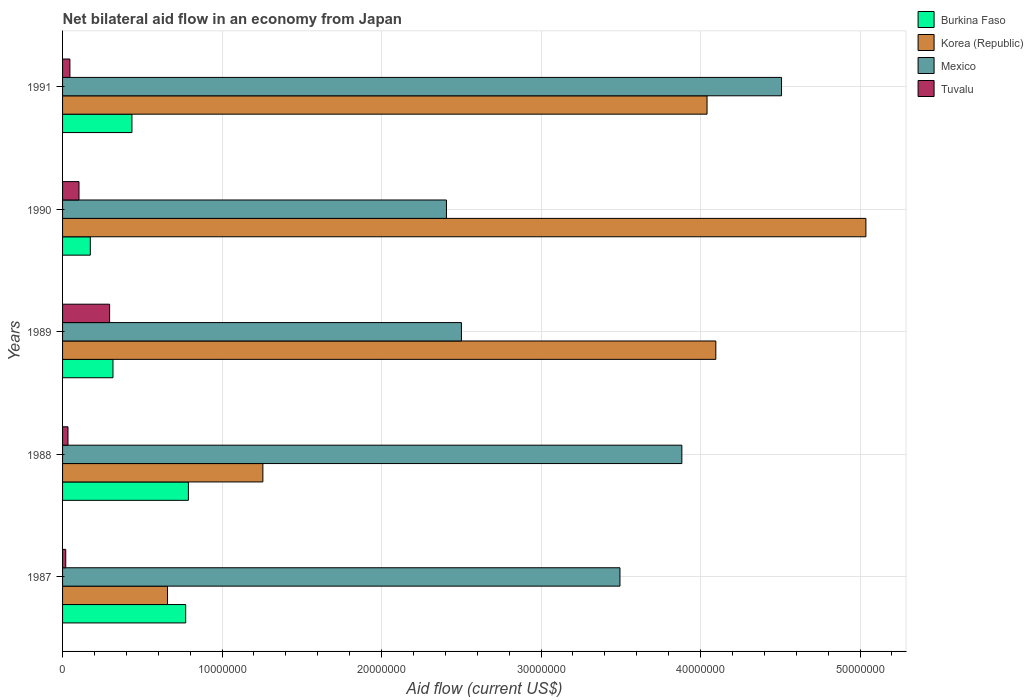How many different coloured bars are there?
Your answer should be compact. 4. How many groups of bars are there?
Keep it short and to the point. 5. Are the number of bars on each tick of the Y-axis equal?
Give a very brief answer. Yes. How many bars are there on the 1st tick from the bottom?
Your response must be concise. 4. What is the label of the 4th group of bars from the top?
Your answer should be compact. 1988. In how many cases, is the number of bars for a given year not equal to the number of legend labels?
Give a very brief answer. 0. What is the net bilateral aid flow in Mexico in 1988?
Make the answer very short. 3.88e+07. Across all years, what is the maximum net bilateral aid flow in Korea (Republic)?
Offer a terse response. 5.04e+07. Across all years, what is the minimum net bilateral aid flow in Mexico?
Provide a succinct answer. 2.41e+07. In which year was the net bilateral aid flow in Tuvalu minimum?
Keep it short and to the point. 1987. What is the total net bilateral aid flow in Tuvalu in the graph?
Your answer should be compact. 4.98e+06. What is the difference between the net bilateral aid flow in Mexico in 1987 and that in 1990?
Provide a succinct answer. 1.09e+07. What is the difference between the net bilateral aid flow in Burkina Faso in 1990 and the net bilateral aid flow in Korea (Republic) in 1989?
Keep it short and to the point. -3.92e+07. What is the average net bilateral aid flow in Mexico per year?
Ensure brevity in your answer.  3.36e+07. In the year 1989, what is the difference between the net bilateral aid flow in Mexico and net bilateral aid flow in Tuvalu?
Ensure brevity in your answer.  2.21e+07. In how many years, is the net bilateral aid flow in Burkina Faso greater than 20000000 US$?
Keep it short and to the point. 0. What is the ratio of the net bilateral aid flow in Tuvalu in 1987 to that in 1990?
Your answer should be very brief. 0.19. Is the net bilateral aid flow in Mexico in 1988 less than that in 1991?
Offer a terse response. Yes. Is the difference between the net bilateral aid flow in Mexico in 1987 and 1990 greater than the difference between the net bilateral aid flow in Tuvalu in 1987 and 1990?
Give a very brief answer. Yes. What is the difference between the highest and the second highest net bilateral aid flow in Mexico?
Keep it short and to the point. 6.25e+06. What is the difference between the highest and the lowest net bilateral aid flow in Burkina Faso?
Your answer should be compact. 6.15e+06. Is the sum of the net bilateral aid flow in Tuvalu in 1987 and 1988 greater than the maximum net bilateral aid flow in Korea (Republic) across all years?
Your answer should be very brief. No. Is it the case that in every year, the sum of the net bilateral aid flow in Burkina Faso and net bilateral aid flow in Tuvalu is greater than the sum of net bilateral aid flow in Mexico and net bilateral aid flow in Korea (Republic)?
Offer a terse response. Yes. What does the 4th bar from the top in 1990 represents?
Provide a succinct answer. Burkina Faso. What does the 1st bar from the bottom in 1989 represents?
Offer a very short reply. Burkina Faso. How many bars are there?
Ensure brevity in your answer.  20. Are the values on the major ticks of X-axis written in scientific E-notation?
Give a very brief answer. No. Does the graph contain any zero values?
Your response must be concise. No. How many legend labels are there?
Your response must be concise. 4. What is the title of the graph?
Provide a succinct answer. Net bilateral aid flow in an economy from Japan. What is the label or title of the X-axis?
Your answer should be compact. Aid flow (current US$). What is the label or title of the Y-axis?
Provide a short and direct response. Years. What is the Aid flow (current US$) in Burkina Faso in 1987?
Offer a very short reply. 7.72e+06. What is the Aid flow (current US$) in Korea (Republic) in 1987?
Give a very brief answer. 6.58e+06. What is the Aid flow (current US$) of Mexico in 1987?
Give a very brief answer. 3.50e+07. What is the Aid flow (current US$) in Tuvalu in 1987?
Make the answer very short. 2.00e+05. What is the Aid flow (current US$) in Burkina Faso in 1988?
Provide a succinct answer. 7.89e+06. What is the Aid flow (current US$) in Korea (Republic) in 1988?
Offer a very short reply. 1.26e+07. What is the Aid flow (current US$) in Mexico in 1988?
Make the answer very short. 3.88e+07. What is the Aid flow (current US$) in Tuvalu in 1988?
Provide a short and direct response. 3.40e+05. What is the Aid flow (current US$) in Burkina Faso in 1989?
Provide a succinct answer. 3.16e+06. What is the Aid flow (current US$) in Korea (Republic) in 1989?
Your answer should be very brief. 4.10e+07. What is the Aid flow (current US$) of Mexico in 1989?
Your answer should be very brief. 2.50e+07. What is the Aid flow (current US$) of Tuvalu in 1989?
Keep it short and to the point. 2.95e+06. What is the Aid flow (current US$) in Burkina Faso in 1990?
Offer a very short reply. 1.74e+06. What is the Aid flow (current US$) of Korea (Republic) in 1990?
Offer a very short reply. 5.04e+07. What is the Aid flow (current US$) in Mexico in 1990?
Ensure brevity in your answer.  2.41e+07. What is the Aid flow (current US$) in Tuvalu in 1990?
Provide a succinct answer. 1.03e+06. What is the Aid flow (current US$) in Burkina Faso in 1991?
Your response must be concise. 4.35e+06. What is the Aid flow (current US$) of Korea (Republic) in 1991?
Provide a succinct answer. 4.04e+07. What is the Aid flow (current US$) of Mexico in 1991?
Offer a terse response. 4.51e+07. Across all years, what is the maximum Aid flow (current US$) in Burkina Faso?
Offer a terse response. 7.89e+06. Across all years, what is the maximum Aid flow (current US$) in Korea (Republic)?
Make the answer very short. 5.04e+07. Across all years, what is the maximum Aid flow (current US$) of Mexico?
Provide a succinct answer. 4.51e+07. Across all years, what is the maximum Aid flow (current US$) in Tuvalu?
Ensure brevity in your answer.  2.95e+06. Across all years, what is the minimum Aid flow (current US$) in Burkina Faso?
Give a very brief answer. 1.74e+06. Across all years, what is the minimum Aid flow (current US$) in Korea (Republic)?
Your answer should be very brief. 6.58e+06. Across all years, what is the minimum Aid flow (current US$) of Mexico?
Ensure brevity in your answer.  2.41e+07. What is the total Aid flow (current US$) of Burkina Faso in the graph?
Give a very brief answer. 2.49e+07. What is the total Aid flow (current US$) of Korea (Republic) in the graph?
Give a very brief answer. 1.51e+08. What is the total Aid flow (current US$) of Mexico in the graph?
Provide a succinct answer. 1.68e+08. What is the total Aid flow (current US$) of Tuvalu in the graph?
Provide a succinct answer. 4.98e+06. What is the difference between the Aid flow (current US$) in Korea (Republic) in 1987 and that in 1988?
Give a very brief answer. -5.98e+06. What is the difference between the Aid flow (current US$) of Mexico in 1987 and that in 1988?
Offer a very short reply. -3.88e+06. What is the difference between the Aid flow (current US$) in Tuvalu in 1987 and that in 1988?
Provide a short and direct response. -1.40e+05. What is the difference between the Aid flow (current US$) of Burkina Faso in 1987 and that in 1989?
Ensure brevity in your answer.  4.56e+06. What is the difference between the Aid flow (current US$) of Korea (Republic) in 1987 and that in 1989?
Provide a succinct answer. -3.44e+07. What is the difference between the Aid flow (current US$) in Mexico in 1987 and that in 1989?
Your response must be concise. 9.94e+06. What is the difference between the Aid flow (current US$) of Tuvalu in 1987 and that in 1989?
Make the answer very short. -2.75e+06. What is the difference between the Aid flow (current US$) in Burkina Faso in 1987 and that in 1990?
Your answer should be very brief. 5.98e+06. What is the difference between the Aid flow (current US$) of Korea (Republic) in 1987 and that in 1990?
Offer a very short reply. -4.38e+07. What is the difference between the Aid flow (current US$) in Mexico in 1987 and that in 1990?
Your answer should be very brief. 1.09e+07. What is the difference between the Aid flow (current US$) of Tuvalu in 1987 and that in 1990?
Offer a terse response. -8.30e+05. What is the difference between the Aid flow (current US$) of Burkina Faso in 1987 and that in 1991?
Ensure brevity in your answer.  3.37e+06. What is the difference between the Aid flow (current US$) in Korea (Republic) in 1987 and that in 1991?
Your response must be concise. -3.38e+07. What is the difference between the Aid flow (current US$) of Mexico in 1987 and that in 1991?
Your response must be concise. -1.01e+07. What is the difference between the Aid flow (current US$) in Burkina Faso in 1988 and that in 1989?
Offer a very short reply. 4.73e+06. What is the difference between the Aid flow (current US$) in Korea (Republic) in 1988 and that in 1989?
Your response must be concise. -2.84e+07. What is the difference between the Aid flow (current US$) of Mexico in 1988 and that in 1989?
Make the answer very short. 1.38e+07. What is the difference between the Aid flow (current US$) in Tuvalu in 1988 and that in 1989?
Offer a very short reply. -2.61e+06. What is the difference between the Aid flow (current US$) of Burkina Faso in 1988 and that in 1990?
Ensure brevity in your answer.  6.15e+06. What is the difference between the Aid flow (current US$) in Korea (Republic) in 1988 and that in 1990?
Provide a short and direct response. -3.78e+07. What is the difference between the Aid flow (current US$) in Mexico in 1988 and that in 1990?
Make the answer very short. 1.48e+07. What is the difference between the Aid flow (current US$) of Tuvalu in 1988 and that in 1990?
Offer a very short reply. -6.90e+05. What is the difference between the Aid flow (current US$) in Burkina Faso in 1988 and that in 1991?
Give a very brief answer. 3.54e+06. What is the difference between the Aid flow (current US$) of Korea (Republic) in 1988 and that in 1991?
Your response must be concise. -2.78e+07. What is the difference between the Aid flow (current US$) in Mexico in 1988 and that in 1991?
Keep it short and to the point. -6.25e+06. What is the difference between the Aid flow (current US$) of Burkina Faso in 1989 and that in 1990?
Keep it short and to the point. 1.42e+06. What is the difference between the Aid flow (current US$) of Korea (Republic) in 1989 and that in 1990?
Provide a short and direct response. -9.41e+06. What is the difference between the Aid flow (current US$) of Mexico in 1989 and that in 1990?
Ensure brevity in your answer.  9.40e+05. What is the difference between the Aid flow (current US$) of Tuvalu in 1989 and that in 1990?
Provide a short and direct response. 1.92e+06. What is the difference between the Aid flow (current US$) in Burkina Faso in 1989 and that in 1991?
Offer a very short reply. -1.19e+06. What is the difference between the Aid flow (current US$) in Korea (Republic) in 1989 and that in 1991?
Ensure brevity in your answer.  5.50e+05. What is the difference between the Aid flow (current US$) in Mexico in 1989 and that in 1991?
Provide a short and direct response. -2.01e+07. What is the difference between the Aid flow (current US$) of Tuvalu in 1989 and that in 1991?
Offer a very short reply. 2.49e+06. What is the difference between the Aid flow (current US$) of Burkina Faso in 1990 and that in 1991?
Ensure brevity in your answer.  -2.61e+06. What is the difference between the Aid flow (current US$) in Korea (Republic) in 1990 and that in 1991?
Make the answer very short. 9.96e+06. What is the difference between the Aid flow (current US$) of Mexico in 1990 and that in 1991?
Your answer should be very brief. -2.10e+07. What is the difference between the Aid flow (current US$) of Tuvalu in 1990 and that in 1991?
Provide a succinct answer. 5.70e+05. What is the difference between the Aid flow (current US$) in Burkina Faso in 1987 and the Aid flow (current US$) in Korea (Republic) in 1988?
Your answer should be compact. -4.84e+06. What is the difference between the Aid flow (current US$) in Burkina Faso in 1987 and the Aid flow (current US$) in Mexico in 1988?
Offer a very short reply. -3.11e+07. What is the difference between the Aid flow (current US$) of Burkina Faso in 1987 and the Aid flow (current US$) of Tuvalu in 1988?
Your response must be concise. 7.38e+06. What is the difference between the Aid flow (current US$) of Korea (Republic) in 1987 and the Aid flow (current US$) of Mexico in 1988?
Your answer should be compact. -3.22e+07. What is the difference between the Aid flow (current US$) of Korea (Republic) in 1987 and the Aid flow (current US$) of Tuvalu in 1988?
Your answer should be compact. 6.24e+06. What is the difference between the Aid flow (current US$) of Mexico in 1987 and the Aid flow (current US$) of Tuvalu in 1988?
Your answer should be very brief. 3.46e+07. What is the difference between the Aid flow (current US$) of Burkina Faso in 1987 and the Aid flow (current US$) of Korea (Republic) in 1989?
Provide a succinct answer. -3.32e+07. What is the difference between the Aid flow (current US$) in Burkina Faso in 1987 and the Aid flow (current US$) in Mexico in 1989?
Keep it short and to the point. -1.73e+07. What is the difference between the Aid flow (current US$) in Burkina Faso in 1987 and the Aid flow (current US$) in Tuvalu in 1989?
Your answer should be very brief. 4.77e+06. What is the difference between the Aid flow (current US$) in Korea (Republic) in 1987 and the Aid flow (current US$) in Mexico in 1989?
Your answer should be very brief. -1.84e+07. What is the difference between the Aid flow (current US$) in Korea (Republic) in 1987 and the Aid flow (current US$) in Tuvalu in 1989?
Give a very brief answer. 3.63e+06. What is the difference between the Aid flow (current US$) of Mexico in 1987 and the Aid flow (current US$) of Tuvalu in 1989?
Offer a terse response. 3.20e+07. What is the difference between the Aid flow (current US$) in Burkina Faso in 1987 and the Aid flow (current US$) in Korea (Republic) in 1990?
Provide a short and direct response. -4.26e+07. What is the difference between the Aid flow (current US$) in Burkina Faso in 1987 and the Aid flow (current US$) in Mexico in 1990?
Your response must be concise. -1.64e+07. What is the difference between the Aid flow (current US$) in Burkina Faso in 1987 and the Aid flow (current US$) in Tuvalu in 1990?
Give a very brief answer. 6.69e+06. What is the difference between the Aid flow (current US$) in Korea (Republic) in 1987 and the Aid flow (current US$) in Mexico in 1990?
Provide a succinct answer. -1.75e+07. What is the difference between the Aid flow (current US$) in Korea (Republic) in 1987 and the Aid flow (current US$) in Tuvalu in 1990?
Your answer should be compact. 5.55e+06. What is the difference between the Aid flow (current US$) of Mexico in 1987 and the Aid flow (current US$) of Tuvalu in 1990?
Make the answer very short. 3.39e+07. What is the difference between the Aid flow (current US$) in Burkina Faso in 1987 and the Aid flow (current US$) in Korea (Republic) in 1991?
Give a very brief answer. -3.27e+07. What is the difference between the Aid flow (current US$) in Burkina Faso in 1987 and the Aid flow (current US$) in Mexico in 1991?
Give a very brief answer. -3.74e+07. What is the difference between the Aid flow (current US$) of Burkina Faso in 1987 and the Aid flow (current US$) of Tuvalu in 1991?
Your response must be concise. 7.26e+06. What is the difference between the Aid flow (current US$) in Korea (Republic) in 1987 and the Aid flow (current US$) in Mexico in 1991?
Your answer should be very brief. -3.85e+07. What is the difference between the Aid flow (current US$) in Korea (Republic) in 1987 and the Aid flow (current US$) in Tuvalu in 1991?
Make the answer very short. 6.12e+06. What is the difference between the Aid flow (current US$) of Mexico in 1987 and the Aid flow (current US$) of Tuvalu in 1991?
Give a very brief answer. 3.45e+07. What is the difference between the Aid flow (current US$) of Burkina Faso in 1988 and the Aid flow (current US$) of Korea (Republic) in 1989?
Offer a very short reply. -3.31e+07. What is the difference between the Aid flow (current US$) in Burkina Faso in 1988 and the Aid flow (current US$) in Mexico in 1989?
Ensure brevity in your answer.  -1.71e+07. What is the difference between the Aid flow (current US$) in Burkina Faso in 1988 and the Aid flow (current US$) in Tuvalu in 1989?
Your response must be concise. 4.94e+06. What is the difference between the Aid flow (current US$) in Korea (Republic) in 1988 and the Aid flow (current US$) in Mexico in 1989?
Offer a terse response. -1.24e+07. What is the difference between the Aid flow (current US$) in Korea (Republic) in 1988 and the Aid flow (current US$) in Tuvalu in 1989?
Keep it short and to the point. 9.61e+06. What is the difference between the Aid flow (current US$) of Mexico in 1988 and the Aid flow (current US$) of Tuvalu in 1989?
Give a very brief answer. 3.59e+07. What is the difference between the Aid flow (current US$) in Burkina Faso in 1988 and the Aid flow (current US$) in Korea (Republic) in 1990?
Your answer should be very brief. -4.25e+07. What is the difference between the Aid flow (current US$) of Burkina Faso in 1988 and the Aid flow (current US$) of Mexico in 1990?
Offer a terse response. -1.62e+07. What is the difference between the Aid flow (current US$) in Burkina Faso in 1988 and the Aid flow (current US$) in Tuvalu in 1990?
Offer a very short reply. 6.86e+06. What is the difference between the Aid flow (current US$) in Korea (Republic) in 1988 and the Aid flow (current US$) in Mexico in 1990?
Your answer should be compact. -1.15e+07. What is the difference between the Aid flow (current US$) of Korea (Republic) in 1988 and the Aid flow (current US$) of Tuvalu in 1990?
Give a very brief answer. 1.15e+07. What is the difference between the Aid flow (current US$) of Mexico in 1988 and the Aid flow (current US$) of Tuvalu in 1990?
Make the answer very short. 3.78e+07. What is the difference between the Aid flow (current US$) in Burkina Faso in 1988 and the Aid flow (current US$) in Korea (Republic) in 1991?
Provide a succinct answer. -3.25e+07. What is the difference between the Aid flow (current US$) in Burkina Faso in 1988 and the Aid flow (current US$) in Mexico in 1991?
Your answer should be very brief. -3.72e+07. What is the difference between the Aid flow (current US$) of Burkina Faso in 1988 and the Aid flow (current US$) of Tuvalu in 1991?
Your answer should be compact. 7.43e+06. What is the difference between the Aid flow (current US$) in Korea (Republic) in 1988 and the Aid flow (current US$) in Mexico in 1991?
Offer a very short reply. -3.25e+07. What is the difference between the Aid flow (current US$) of Korea (Republic) in 1988 and the Aid flow (current US$) of Tuvalu in 1991?
Ensure brevity in your answer.  1.21e+07. What is the difference between the Aid flow (current US$) of Mexico in 1988 and the Aid flow (current US$) of Tuvalu in 1991?
Offer a terse response. 3.84e+07. What is the difference between the Aid flow (current US$) of Burkina Faso in 1989 and the Aid flow (current US$) of Korea (Republic) in 1990?
Offer a very short reply. -4.72e+07. What is the difference between the Aid flow (current US$) of Burkina Faso in 1989 and the Aid flow (current US$) of Mexico in 1990?
Give a very brief answer. -2.09e+07. What is the difference between the Aid flow (current US$) in Burkina Faso in 1989 and the Aid flow (current US$) in Tuvalu in 1990?
Give a very brief answer. 2.13e+06. What is the difference between the Aid flow (current US$) in Korea (Republic) in 1989 and the Aid flow (current US$) in Mexico in 1990?
Provide a short and direct response. 1.69e+07. What is the difference between the Aid flow (current US$) of Korea (Republic) in 1989 and the Aid flow (current US$) of Tuvalu in 1990?
Your response must be concise. 3.99e+07. What is the difference between the Aid flow (current US$) in Mexico in 1989 and the Aid flow (current US$) in Tuvalu in 1990?
Keep it short and to the point. 2.40e+07. What is the difference between the Aid flow (current US$) in Burkina Faso in 1989 and the Aid flow (current US$) in Korea (Republic) in 1991?
Ensure brevity in your answer.  -3.72e+07. What is the difference between the Aid flow (current US$) in Burkina Faso in 1989 and the Aid flow (current US$) in Mexico in 1991?
Make the answer very short. -4.19e+07. What is the difference between the Aid flow (current US$) in Burkina Faso in 1989 and the Aid flow (current US$) in Tuvalu in 1991?
Your response must be concise. 2.70e+06. What is the difference between the Aid flow (current US$) in Korea (Republic) in 1989 and the Aid flow (current US$) in Mexico in 1991?
Your response must be concise. -4.12e+06. What is the difference between the Aid flow (current US$) of Korea (Republic) in 1989 and the Aid flow (current US$) of Tuvalu in 1991?
Keep it short and to the point. 4.05e+07. What is the difference between the Aid flow (current US$) in Mexico in 1989 and the Aid flow (current US$) in Tuvalu in 1991?
Offer a terse response. 2.46e+07. What is the difference between the Aid flow (current US$) in Burkina Faso in 1990 and the Aid flow (current US$) in Korea (Republic) in 1991?
Offer a terse response. -3.87e+07. What is the difference between the Aid flow (current US$) in Burkina Faso in 1990 and the Aid flow (current US$) in Mexico in 1991?
Your response must be concise. -4.33e+07. What is the difference between the Aid flow (current US$) in Burkina Faso in 1990 and the Aid flow (current US$) in Tuvalu in 1991?
Offer a terse response. 1.28e+06. What is the difference between the Aid flow (current US$) in Korea (Republic) in 1990 and the Aid flow (current US$) in Mexico in 1991?
Provide a short and direct response. 5.29e+06. What is the difference between the Aid flow (current US$) of Korea (Republic) in 1990 and the Aid flow (current US$) of Tuvalu in 1991?
Make the answer very short. 4.99e+07. What is the difference between the Aid flow (current US$) of Mexico in 1990 and the Aid flow (current US$) of Tuvalu in 1991?
Offer a terse response. 2.36e+07. What is the average Aid flow (current US$) of Burkina Faso per year?
Offer a very short reply. 4.97e+06. What is the average Aid flow (current US$) in Korea (Republic) per year?
Offer a terse response. 3.02e+07. What is the average Aid flow (current US$) of Mexico per year?
Ensure brevity in your answer.  3.36e+07. What is the average Aid flow (current US$) in Tuvalu per year?
Offer a very short reply. 9.96e+05. In the year 1987, what is the difference between the Aid flow (current US$) of Burkina Faso and Aid flow (current US$) of Korea (Republic)?
Your answer should be compact. 1.14e+06. In the year 1987, what is the difference between the Aid flow (current US$) in Burkina Faso and Aid flow (current US$) in Mexico?
Offer a terse response. -2.72e+07. In the year 1987, what is the difference between the Aid flow (current US$) in Burkina Faso and Aid flow (current US$) in Tuvalu?
Keep it short and to the point. 7.52e+06. In the year 1987, what is the difference between the Aid flow (current US$) in Korea (Republic) and Aid flow (current US$) in Mexico?
Provide a succinct answer. -2.84e+07. In the year 1987, what is the difference between the Aid flow (current US$) of Korea (Republic) and Aid flow (current US$) of Tuvalu?
Provide a succinct answer. 6.38e+06. In the year 1987, what is the difference between the Aid flow (current US$) of Mexico and Aid flow (current US$) of Tuvalu?
Offer a very short reply. 3.48e+07. In the year 1988, what is the difference between the Aid flow (current US$) of Burkina Faso and Aid flow (current US$) of Korea (Republic)?
Give a very brief answer. -4.67e+06. In the year 1988, what is the difference between the Aid flow (current US$) in Burkina Faso and Aid flow (current US$) in Mexico?
Ensure brevity in your answer.  -3.09e+07. In the year 1988, what is the difference between the Aid flow (current US$) of Burkina Faso and Aid flow (current US$) of Tuvalu?
Keep it short and to the point. 7.55e+06. In the year 1988, what is the difference between the Aid flow (current US$) of Korea (Republic) and Aid flow (current US$) of Mexico?
Your answer should be compact. -2.63e+07. In the year 1988, what is the difference between the Aid flow (current US$) in Korea (Republic) and Aid flow (current US$) in Tuvalu?
Ensure brevity in your answer.  1.22e+07. In the year 1988, what is the difference between the Aid flow (current US$) of Mexico and Aid flow (current US$) of Tuvalu?
Your response must be concise. 3.85e+07. In the year 1989, what is the difference between the Aid flow (current US$) in Burkina Faso and Aid flow (current US$) in Korea (Republic)?
Your answer should be compact. -3.78e+07. In the year 1989, what is the difference between the Aid flow (current US$) of Burkina Faso and Aid flow (current US$) of Mexico?
Your answer should be compact. -2.18e+07. In the year 1989, what is the difference between the Aid flow (current US$) in Korea (Republic) and Aid flow (current US$) in Mexico?
Ensure brevity in your answer.  1.60e+07. In the year 1989, what is the difference between the Aid flow (current US$) in Korea (Republic) and Aid flow (current US$) in Tuvalu?
Make the answer very short. 3.80e+07. In the year 1989, what is the difference between the Aid flow (current US$) of Mexico and Aid flow (current US$) of Tuvalu?
Your answer should be very brief. 2.21e+07. In the year 1990, what is the difference between the Aid flow (current US$) of Burkina Faso and Aid flow (current US$) of Korea (Republic)?
Give a very brief answer. -4.86e+07. In the year 1990, what is the difference between the Aid flow (current US$) of Burkina Faso and Aid flow (current US$) of Mexico?
Keep it short and to the point. -2.23e+07. In the year 1990, what is the difference between the Aid flow (current US$) of Burkina Faso and Aid flow (current US$) of Tuvalu?
Offer a terse response. 7.10e+05. In the year 1990, what is the difference between the Aid flow (current US$) in Korea (Republic) and Aid flow (current US$) in Mexico?
Keep it short and to the point. 2.63e+07. In the year 1990, what is the difference between the Aid flow (current US$) of Korea (Republic) and Aid flow (current US$) of Tuvalu?
Keep it short and to the point. 4.93e+07. In the year 1990, what is the difference between the Aid flow (current US$) in Mexico and Aid flow (current US$) in Tuvalu?
Your response must be concise. 2.30e+07. In the year 1991, what is the difference between the Aid flow (current US$) in Burkina Faso and Aid flow (current US$) in Korea (Republic)?
Provide a succinct answer. -3.61e+07. In the year 1991, what is the difference between the Aid flow (current US$) of Burkina Faso and Aid flow (current US$) of Mexico?
Provide a succinct answer. -4.07e+07. In the year 1991, what is the difference between the Aid flow (current US$) of Burkina Faso and Aid flow (current US$) of Tuvalu?
Give a very brief answer. 3.89e+06. In the year 1991, what is the difference between the Aid flow (current US$) in Korea (Republic) and Aid flow (current US$) in Mexico?
Ensure brevity in your answer.  -4.67e+06. In the year 1991, what is the difference between the Aid flow (current US$) of Korea (Republic) and Aid flow (current US$) of Tuvalu?
Offer a very short reply. 4.00e+07. In the year 1991, what is the difference between the Aid flow (current US$) in Mexico and Aid flow (current US$) in Tuvalu?
Ensure brevity in your answer.  4.46e+07. What is the ratio of the Aid flow (current US$) in Burkina Faso in 1987 to that in 1988?
Make the answer very short. 0.98. What is the ratio of the Aid flow (current US$) in Korea (Republic) in 1987 to that in 1988?
Your answer should be very brief. 0.52. What is the ratio of the Aid flow (current US$) of Mexico in 1987 to that in 1988?
Your answer should be compact. 0.9. What is the ratio of the Aid flow (current US$) of Tuvalu in 1987 to that in 1988?
Your answer should be very brief. 0.59. What is the ratio of the Aid flow (current US$) of Burkina Faso in 1987 to that in 1989?
Provide a succinct answer. 2.44. What is the ratio of the Aid flow (current US$) of Korea (Republic) in 1987 to that in 1989?
Your answer should be very brief. 0.16. What is the ratio of the Aid flow (current US$) of Mexico in 1987 to that in 1989?
Provide a succinct answer. 1.4. What is the ratio of the Aid flow (current US$) in Tuvalu in 1987 to that in 1989?
Give a very brief answer. 0.07. What is the ratio of the Aid flow (current US$) in Burkina Faso in 1987 to that in 1990?
Make the answer very short. 4.44. What is the ratio of the Aid flow (current US$) in Korea (Republic) in 1987 to that in 1990?
Make the answer very short. 0.13. What is the ratio of the Aid flow (current US$) in Mexico in 1987 to that in 1990?
Your answer should be compact. 1.45. What is the ratio of the Aid flow (current US$) of Tuvalu in 1987 to that in 1990?
Your answer should be very brief. 0.19. What is the ratio of the Aid flow (current US$) in Burkina Faso in 1987 to that in 1991?
Your answer should be compact. 1.77. What is the ratio of the Aid flow (current US$) of Korea (Republic) in 1987 to that in 1991?
Make the answer very short. 0.16. What is the ratio of the Aid flow (current US$) of Mexico in 1987 to that in 1991?
Provide a short and direct response. 0.78. What is the ratio of the Aid flow (current US$) of Tuvalu in 1987 to that in 1991?
Keep it short and to the point. 0.43. What is the ratio of the Aid flow (current US$) in Burkina Faso in 1988 to that in 1989?
Your response must be concise. 2.5. What is the ratio of the Aid flow (current US$) in Korea (Republic) in 1988 to that in 1989?
Your response must be concise. 0.31. What is the ratio of the Aid flow (current US$) in Mexico in 1988 to that in 1989?
Provide a succinct answer. 1.55. What is the ratio of the Aid flow (current US$) in Tuvalu in 1988 to that in 1989?
Ensure brevity in your answer.  0.12. What is the ratio of the Aid flow (current US$) in Burkina Faso in 1988 to that in 1990?
Offer a terse response. 4.53. What is the ratio of the Aid flow (current US$) in Korea (Republic) in 1988 to that in 1990?
Your answer should be very brief. 0.25. What is the ratio of the Aid flow (current US$) of Mexico in 1988 to that in 1990?
Offer a very short reply. 1.61. What is the ratio of the Aid flow (current US$) of Tuvalu in 1988 to that in 1990?
Your answer should be compact. 0.33. What is the ratio of the Aid flow (current US$) in Burkina Faso in 1988 to that in 1991?
Offer a very short reply. 1.81. What is the ratio of the Aid flow (current US$) of Korea (Republic) in 1988 to that in 1991?
Ensure brevity in your answer.  0.31. What is the ratio of the Aid flow (current US$) in Mexico in 1988 to that in 1991?
Keep it short and to the point. 0.86. What is the ratio of the Aid flow (current US$) of Tuvalu in 1988 to that in 1991?
Make the answer very short. 0.74. What is the ratio of the Aid flow (current US$) in Burkina Faso in 1989 to that in 1990?
Your answer should be compact. 1.82. What is the ratio of the Aid flow (current US$) in Korea (Republic) in 1989 to that in 1990?
Give a very brief answer. 0.81. What is the ratio of the Aid flow (current US$) in Mexico in 1989 to that in 1990?
Offer a very short reply. 1.04. What is the ratio of the Aid flow (current US$) in Tuvalu in 1989 to that in 1990?
Your answer should be very brief. 2.86. What is the ratio of the Aid flow (current US$) in Burkina Faso in 1989 to that in 1991?
Give a very brief answer. 0.73. What is the ratio of the Aid flow (current US$) in Korea (Republic) in 1989 to that in 1991?
Ensure brevity in your answer.  1.01. What is the ratio of the Aid flow (current US$) of Mexico in 1989 to that in 1991?
Provide a short and direct response. 0.55. What is the ratio of the Aid flow (current US$) in Tuvalu in 1989 to that in 1991?
Offer a very short reply. 6.41. What is the ratio of the Aid flow (current US$) in Burkina Faso in 1990 to that in 1991?
Give a very brief answer. 0.4. What is the ratio of the Aid flow (current US$) in Korea (Republic) in 1990 to that in 1991?
Ensure brevity in your answer.  1.25. What is the ratio of the Aid flow (current US$) in Mexico in 1990 to that in 1991?
Ensure brevity in your answer.  0.53. What is the ratio of the Aid flow (current US$) in Tuvalu in 1990 to that in 1991?
Make the answer very short. 2.24. What is the difference between the highest and the second highest Aid flow (current US$) of Korea (Republic)?
Provide a short and direct response. 9.41e+06. What is the difference between the highest and the second highest Aid flow (current US$) of Mexico?
Offer a very short reply. 6.25e+06. What is the difference between the highest and the second highest Aid flow (current US$) in Tuvalu?
Provide a succinct answer. 1.92e+06. What is the difference between the highest and the lowest Aid flow (current US$) of Burkina Faso?
Keep it short and to the point. 6.15e+06. What is the difference between the highest and the lowest Aid flow (current US$) of Korea (Republic)?
Provide a short and direct response. 4.38e+07. What is the difference between the highest and the lowest Aid flow (current US$) of Mexico?
Your response must be concise. 2.10e+07. What is the difference between the highest and the lowest Aid flow (current US$) in Tuvalu?
Your answer should be very brief. 2.75e+06. 